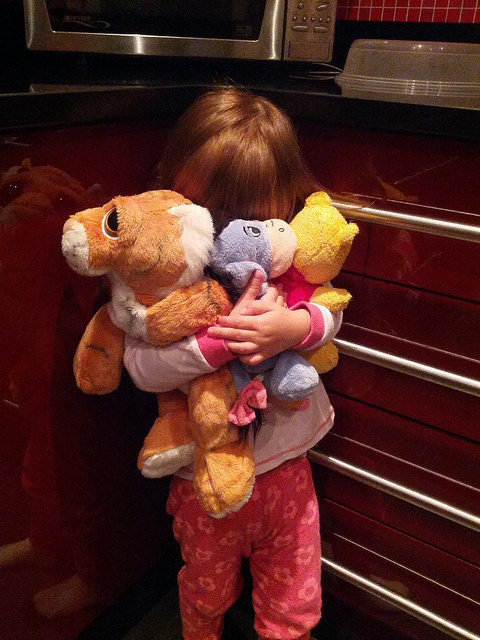Describe the objects in this image and their specific colors. I can see people in black, maroon, and brown tones, microwave in black, maroon, and gray tones, bowl in black, maroon, brown, and gray tones, and teddy bear in black, brown, gold, and orange tones in this image. 